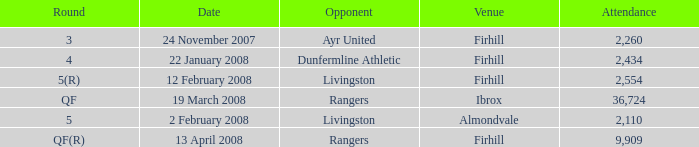Who was the opponent at the qf(r) round? Rangers. 